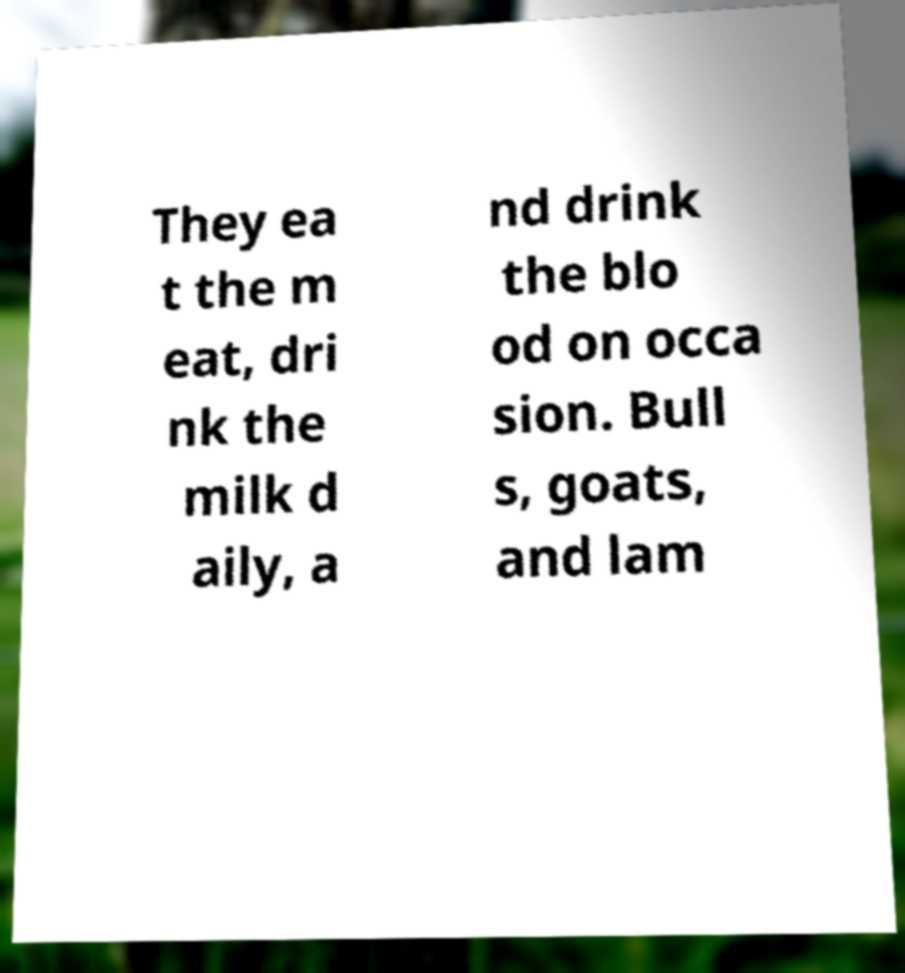I need the written content from this picture converted into text. Can you do that? They ea t the m eat, dri nk the milk d aily, a nd drink the blo od on occa sion. Bull s, goats, and lam 